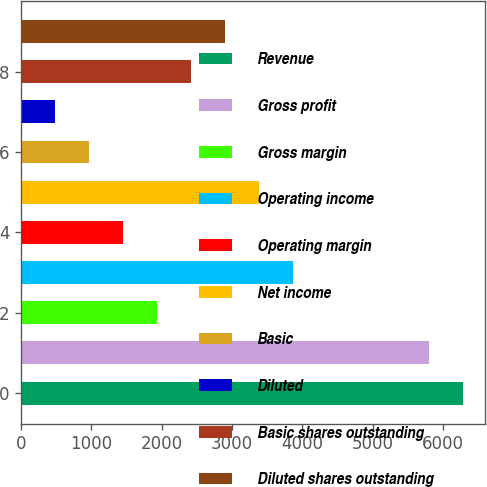<chart> <loc_0><loc_0><loc_500><loc_500><bar_chart><fcel>Revenue<fcel>Gross profit<fcel>Gross margin<fcel>Operating income<fcel>Operating margin<fcel>Net income<fcel>Basic<fcel>Diluted<fcel>Basic shares outstanding<fcel>Diluted shares outstanding<nl><fcel>6282.76<fcel>5799.51<fcel>1933.51<fcel>3866.51<fcel>1450.26<fcel>3383.26<fcel>967.01<fcel>483.76<fcel>2416.76<fcel>2900.01<nl></chart> 